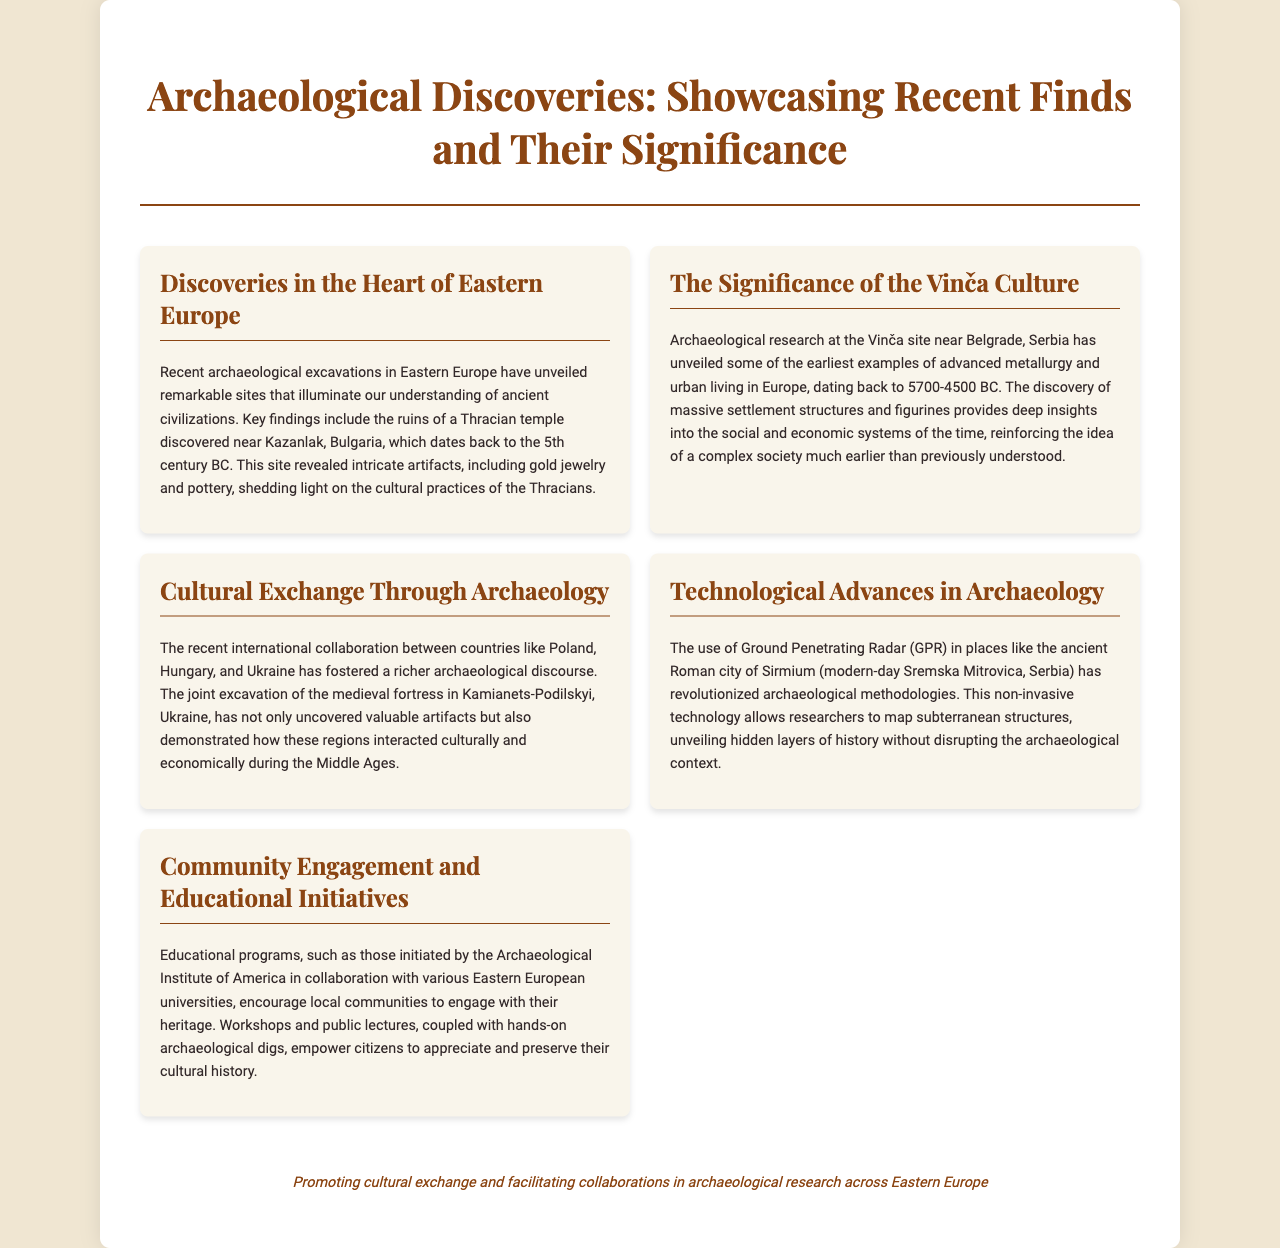What ancient site was discovered near Kazanlak? The document states that the ruins of a Thracian temple were discovered near Kazanlak, Bulgaria.
Answer: Thracian temple What time period does the Vinča culture date back to? The document mentions that the Vinča culture dates back to 5700-4500 BC.
Answer: 5700-4500 BC Which non-invasive technology is mentioned in the document? Ground Penetrating Radar (GPR) is highlighted as a technological advance in archaeology.
Answer: Ground Penetrating Radar Which countries collaborated on the excavation in Kamianets-Podilskyi? The document lists Poland, Hungary, and Ukraine as the countries involved in the collaboration.
Answer: Poland, Hungary, Ukraine What is the purpose of educational programs mentioned in the brochure? The purpose of these educational programs is to encourage local communities to engage with their heritage.
Answer: Engage with their heritage What type of discoveries are highlighted in the brochure? The brochure showcases recent archaeological discoveries.
Answer: Recent archaeological discoveries Why is the Thracian temple significant? The significance comes from the intricate artifacts, including gold jewelry and pottery, that provide insights into Thracian culture.
Answer: Cultural practices of the Thracians What event does the brochure emphasize regarding international collaboration? The brochure emphasizes the joint excavation of a medieval fortress as a key event.
Answer: Joint excavation of the medieval fortress What is the overall aim of the document's footer? The footer promotes cultural exchange and collaboration in archaeological research.
Answer: Cultural exchange and collaboration 